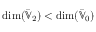<formula> <loc_0><loc_0><loc_500><loc_500>\dim ( \bar { \mathbb { V } } _ { 2 } ) < \dim ( \bar { \mathbb { V } } _ { 0 } )</formula> 